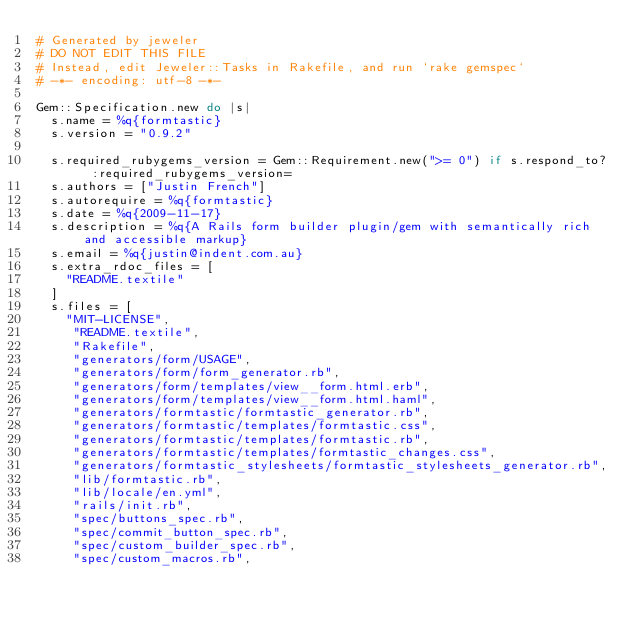<code> <loc_0><loc_0><loc_500><loc_500><_Ruby_># Generated by jeweler
# DO NOT EDIT THIS FILE
# Instead, edit Jeweler::Tasks in Rakefile, and run `rake gemspec`
# -*- encoding: utf-8 -*-

Gem::Specification.new do |s|
  s.name = %q{formtastic}
  s.version = "0.9.2"

  s.required_rubygems_version = Gem::Requirement.new(">= 0") if s.respond_to? :required_rubygems_version=
  s.authors = ["Justin French"]
  s.autorequire = %q{formtastic}
  s.date = %q{2009-11-17}
  s.description = %q{A Rails form builder plugin/gem with semantically rich and accessible markup}
  s.email = %q{justin@indent.com.au}
  s.extra_rdoc_files = [
    "README.textile"
  ]
  s.files = [
    "MIT-LICENSE",
     "README.textile",
     "Rakefile",
     "generators/form/USAGE",
     "generators/form/form_generator.rb",
     "generators/form/templates/view__form.html.erb",
     "generators/form/templates/view__form.html.haml",
     "generators/formtastic/formtastic_generator.rb",
     "generators/formtastic/templates/formtastic.css",
     "generators/formtastic/templates/formtastic.rb",
     "generators/formtastic/templates/formtastic_changes.css",
     "generators/formtastic_stylesheets/formtastic_stylesheets_generator.rb",
     "lib/formtastic.rb",
     "lib/locale/en.yml",
     "rails/init.rb",
     "spec/buttons_spec.rb",
     "spec/commit_button_spec.rb",
     "spec/custom_builder_spec.rb",
     "spec/custom_macros.rb",</code> 